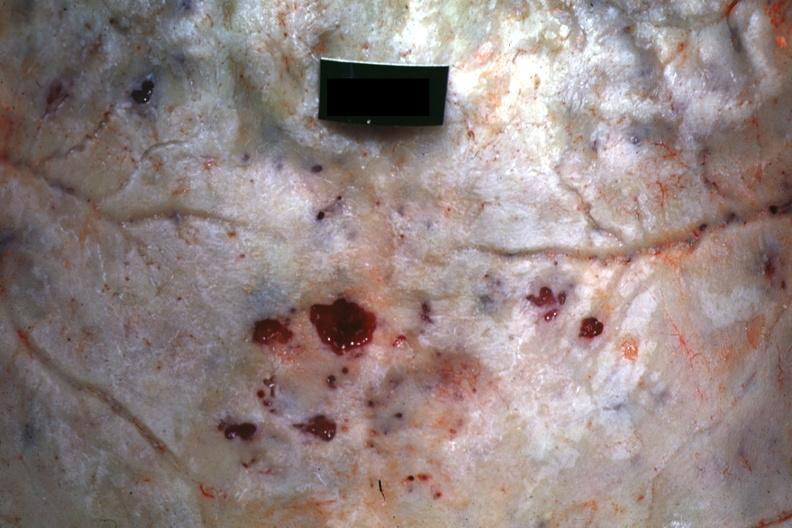what is present?
Answer the question using a single word or phrase. Bone 